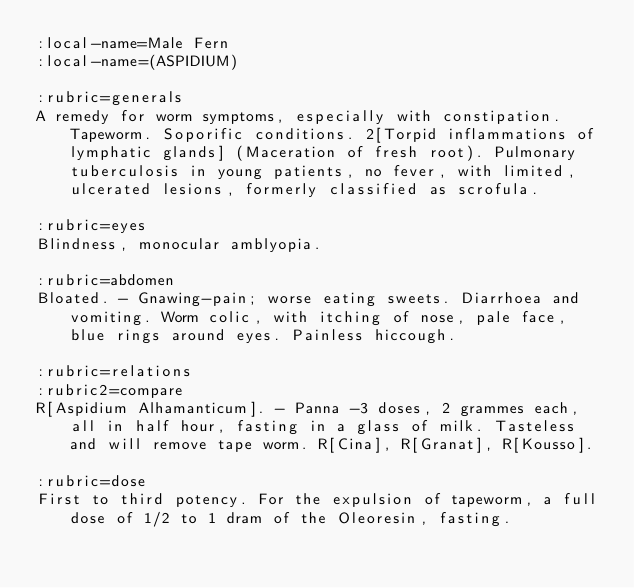<code> <loc_0><loc_0><loc_500><loc_500><_ObjectiveC_>:local-name=Male Fern
:local-name=(ASPIDIUM)

:rubric=generals
A remedy for worm symptoms, especially with constipation. Tapeworm. Soporific conditions. 2[Torpid inflammations of lymphatic glands] (Maceration of fresh root). Pulmonary tuberculosis in young patients, no fever, with limited, ulcerated lesions, formerly classified as scrofula.

:rubric=eyes
Blindness, monocular amblyopia.

:rubric=abdomen
Bloated. - Gnawing-pain; worse eating sweets. Diarrhoea and vomiting. Worm colic, with itching of nose, pale face, blue rings around eyes. Painless hiccough.

:rubric=relations
:rubric2=compare
R[Aspidium Alhamanticum]. - Panna -3 doses, 2 grammes each, all in half hour, fasting in a glass of milk. Tasteless and will remove tape worm. R[Cina], R[Granat], R[Kousso].

:rubric=dose
First to third potency. For the expulsion of tapeworm, a full dose of 1/2 to 1 dram of the Oleoresin, fasting.

</code> 